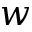Convert formula to latex. <formula><loc_0><loc_0><loc_500><loc_500>w</formula> 